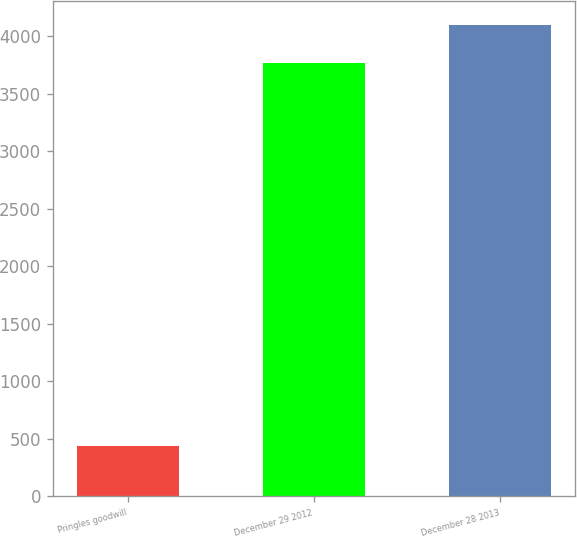<chart> <loc_0><loc_0><loc_500><loc_500><bar_chart><fcel>Pringles goodwill<fcel>December 29 2012<fcel>December 28 2013<nl><fcel>434<fcel>3767<fcel>4101.5<nl></chart> 